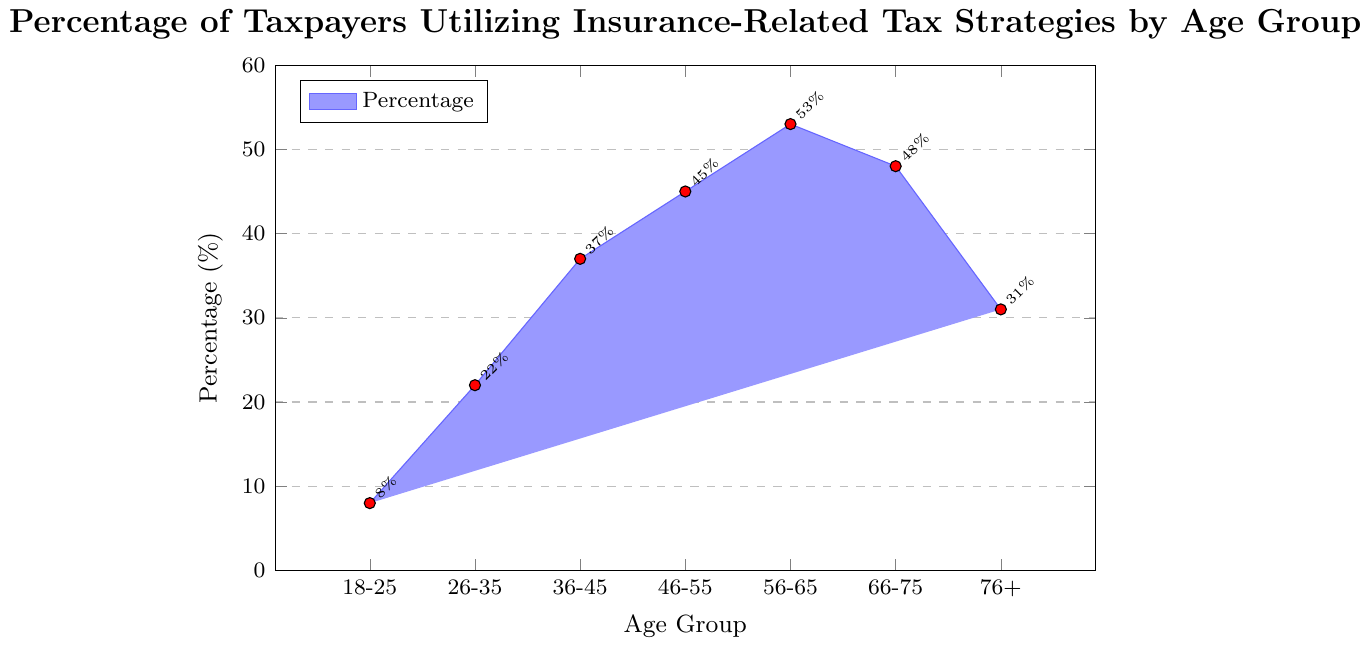Which age group has the highest percentage of taxpayers utilizing insurance-related tax strategies? To determine the age group with the highest percentage, look at the bar heights and the values displayed near them in the figure. The highest percentage is 53%, which corresponds to the 56-65 age group.
Answer: 56-65 Which age group has the lowest percentage of taxpayers utilizing insurance-related tax strategies? Observing the heights of the bars, the shortest bar represents the minimum percentage. The lowest value is 8%, which belongs to the 18-25 age group.
Answer: 18-25 What is the percentage difference between the 26-35 and 56-65 age groups? The percentage for the 26-35 age group is 22%, and for the 56-65 age group, it is 53%. Subtracting these gives 53% - 22% = 31%.
Answer: 31% What is the sum of the percentages for the 36-45 and 66-75 age groups? The percentage for the 36-45 age group is 37%, and for the 66-75 age group, it is 48%. Adding these together gives 37% + 48% = 85%.
Answer: 85% Between which two consecutive age groups is the largest increase in percentage observed? By comparing the differences between consecutive age groups (26-35: 22%, 36-45: 37%, 46-55: 45%, 56-65: 53%, 66-75: 48%, 76+: 31%), the biggest increase occurs between 26-35 (22%) and 36-45 (37%), which is 37% - 22% = 15%.
Answer: 26-35 to 36-45 What is the average percentage of taxpayers utilizing insurance-related tax strategies across all age groups? To calculate the average, sum up all the percentages and divide by the number of age groups: (8 + 22 + 37 + 45 + 53 + 48 + 31) / 7 = 34.86%.
Answer: 34.86% In general, does the percentage of taxpayers utilizing insurance-related tax strategies increase with age? Observing the trend in the bar heights, the percentages mostly increase with age up to the 56-65 group, then slightly decrease for the 66-75 and 76+ groups, indicating a general increasing trend with a late decline.
Answer: Yes, generally Which visual feature is used to distinguish the value labels near the bars? The value labels near the bars are distinguished by their small, rotated text format, which is marked with a red dot close to the top of each bar.
Answer: Red dots and rotated text How does the percentage for the 46-55 age group compare to that for the 66-75 age group? The percentage for the 46-55 age group is 45%, and for the 66-75 age group, it is 48%. 45% is less than 48%, indicating the percentage for the 46-55 age group is slightly lower.
Answer: Less Which age groups have a percentage above the overall average? The overall average percentage is calculated as 34.86%. The age groups with percentages above this average are 46-55 (45%), 56-65 (53%), and 66-75 (48%).
Answer: 46-55, 56-65, 66-75 